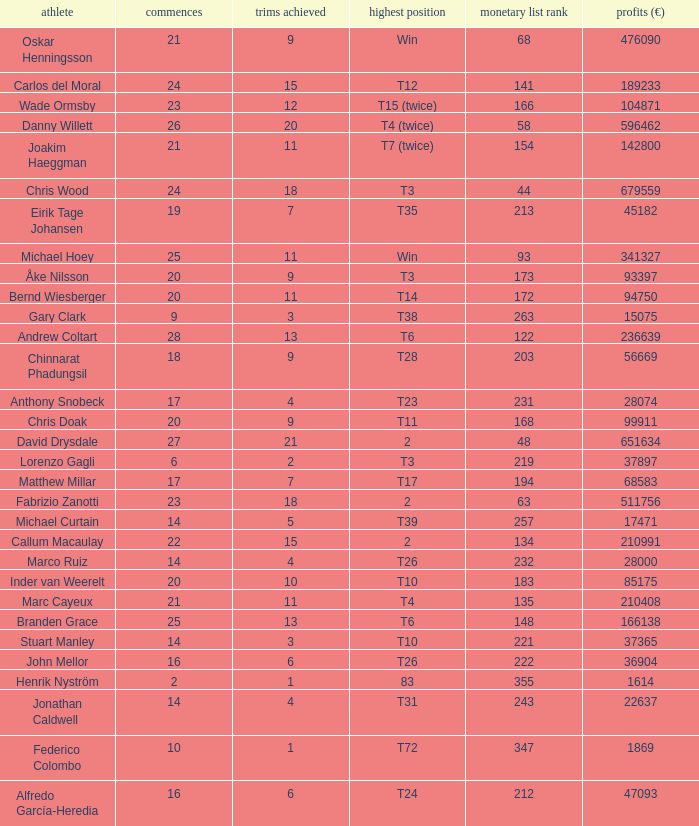How many times did bernd wiesberger manage to make cuts? 11.0. Give me the full table as a dictionary. {'header': ['athlete', 'commences', 'trims achieved', 'highest position', 'monetary list rank', 'profits (€)'], 'rows': [['Oskar Henningsson', '21', '9', 'Win', '68', '476090'], ['Carlos del Moral', '24', '15', 'T12', '141', '189233'], ['Wade Ormsby', '23', '12', 'T15 (twice)', '166', '104871'], ['Danny Willett', '26', '20', 'T4 (twice)', '58', '596462'], ['Joakim Haeggman', '21', '11', 'T7 (twice)', '154', '142800'], ['Chris Wood', '24', '18', 'T3', '44', '679559'], ['Eirik Tage Johansen', '19', '7', 'T35', '213', '45182'], ['Michael Hoey', '25', '11', 'Win', '93', '341327'], ['Åke Nilsson', '20', '9', 'T3', '173', '93397'], ['Bernd Wiesberger', '20', '11', 'T14', '172', '94750'], ['Gary Clark', '9', '3', 'T38', '263', '15075'], ['Andrew Coltart', '28', '13', 'T6', '122', '236639'], ['Chinnarat Phadungsil', '18', '9', 'T28', '203', '56669'], ['Anthony Snobeck', '17', '4', 'T23', '231', '28074'], ['Chris Doak', '20', '9', 'T11', '168', '99911'], ['David Drysdale', '27', '21', '2', '48', '651634'], ['Lorenzo Gagli', '6', '2', 'T3', '219', '37897'], ['Matthew Millar', '17', '7', 'T17', '194', '68583'], ['Fabrizio Zanotti', '23', '18', '2', '63', '511756'], ['Michael Curtain', '14', '5', 'T39', '257', '17471'], ['Callum Macaulay', '22', '15', '2', '134', '210991'], ['Marco Ruiz', '14', '4', 'T26', '232', '28000'], ['Inder van Weerelt', '20', '10', 'T10', '183', '85175'], ['Marc Cayeux', '21', '11', 'T4', '135', '210408'], ['Branden Grace', '25', '13', 'T6', '148', '166138'], ['Stuart Manley', '14', '3', 'T10', '221', '37365'], ['John Mellor', '16', '6', 'T26', '222', '36904'], ['Henrik Nyström', '2', '1', '83', '355', '1614'], ['Jonathan Caldwell', '14', '4', 'T31', '243', '22637'], ['Federico Colombo', '10', '1', 'T72', '347', '1869'], ['Alfredo García-Heredia', '16', '6', 'T24', '212', '47093']]} 